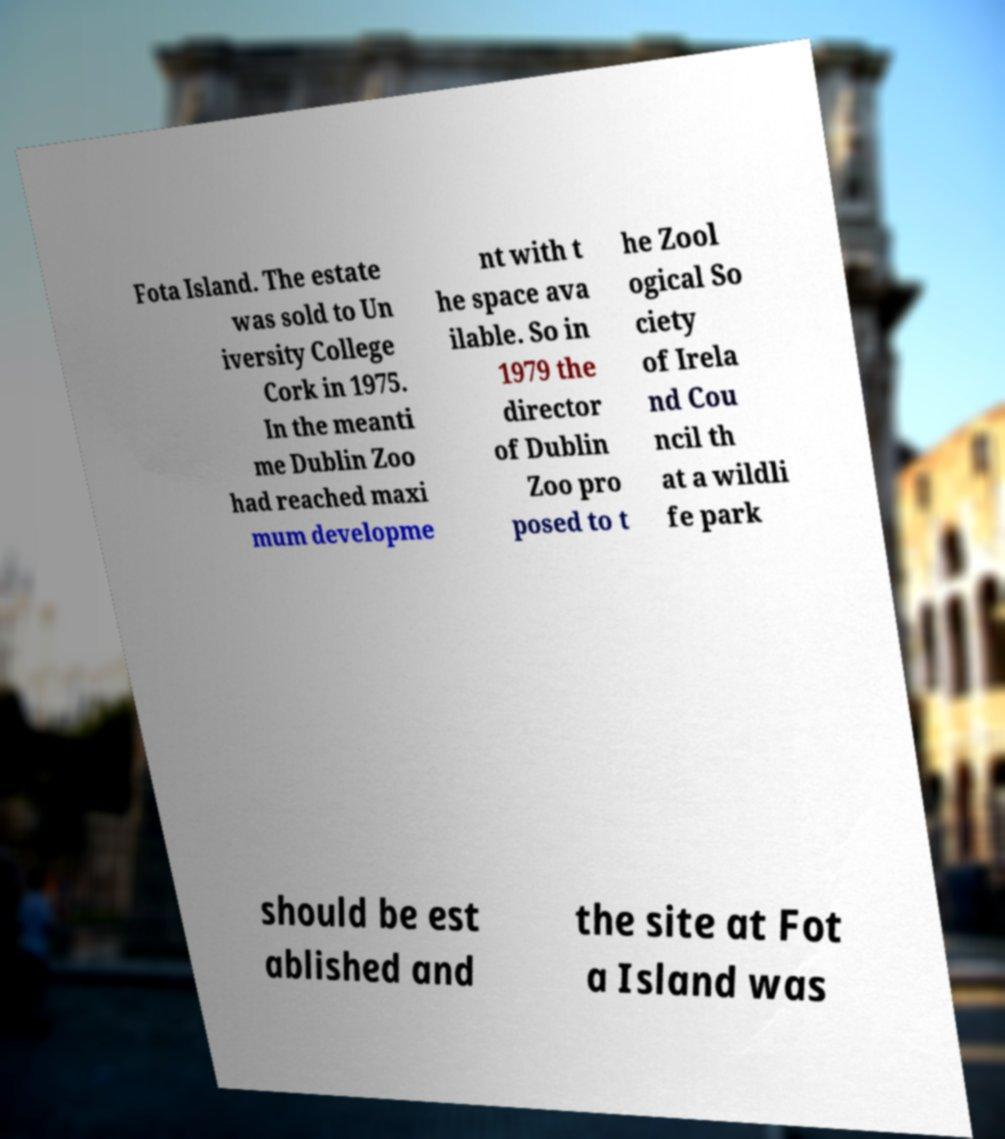Could you extract and type out the text from this image? Fota Island. The estate was sold to Un iversity College Cork in 1975. In the meanti me Dublin Zoo had reached maxi mum developme nt with t he space ava ilable. So in 1979 the director of Dublin Zoo pro posed to t he Zool ogical So ciety of Irela nd Cou ncil th at a wildli fe park should be est ablished and the site at Fot a Island was 